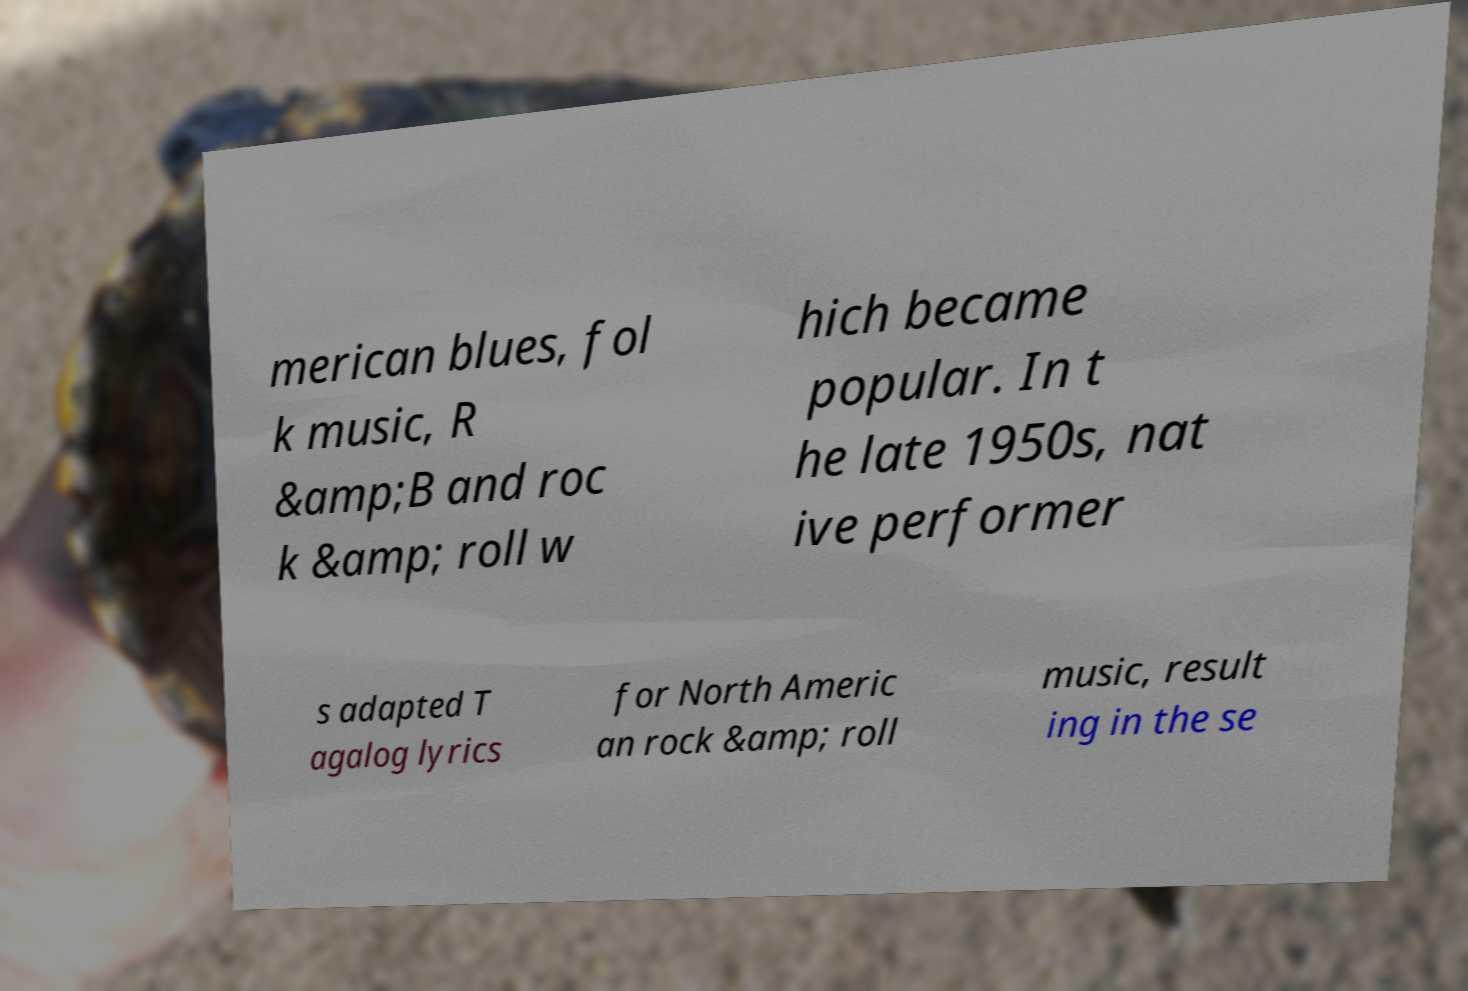Could you assist in decoding the text presented in this image and type it out clearly? merican blues, fol k music, R &amp;B and roc k &amp; roll w hich became popular. In t he late 1950s, nat ive performer s adapted T agalog lyrics for North Americ an rock &amp; roll music, result ing in the se 